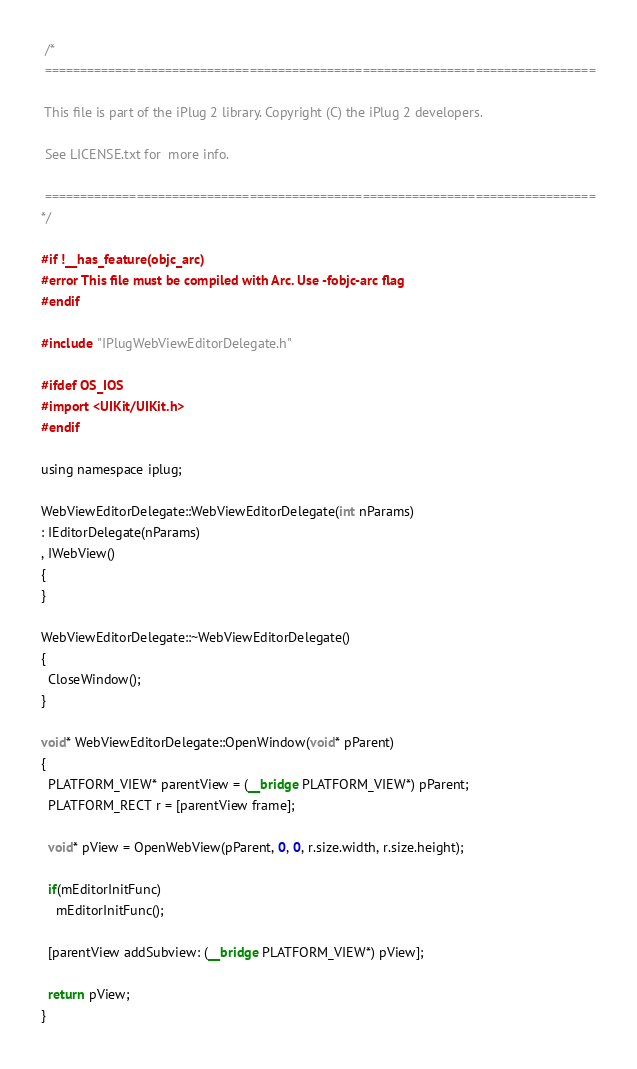<code> <loc_0><loc_0><loc_500><loc_500><_ObjectiveC_> /*
 ==============================================================================
 
 This file is part of the iPlug 2 library. Copyright (C) the iPlug 2 developers.
 
 See LICENSE.txt for  more info.
 
 ==============================================================================
*/

#if !__has_feature(objc_arc)
#error This file must be compiled with Arc. Use -fobjc-arc flag
#endif

#include "IPlugWebViewEditorDelegate.h"

#ifdef OS_IOS
#import <UIKit/UIKit.h>
#endif

using namespace iplug;

WebViewEditorDelegate::WebViewEditorDelegate(int nParams)
: IEditorDelegate(nParams)
, IWebView()
{
}

WebViewEditorDelegate::~WebViewEditorDelegate()
{
  CloseWindow();
}

void* WebViewEditorDelegate::OpenWindow(void* pParent)
{
  PLATFORM_VIEW* parentView = (__bridge PLATFORM_VIEW*) pParent;
  PLATFORM_RECT r = [parentView frame];
  
  void* pView = OpenWebView(pParent, 0, 0, r.size.width, r.size.height);
  
  if(mEditorInitFunc)
    mEditorInitFunc();
  
  [parentView addSubview: (__bridge PLATFORM_VIEW*) pView];
    
  return pView;
}
</code> 